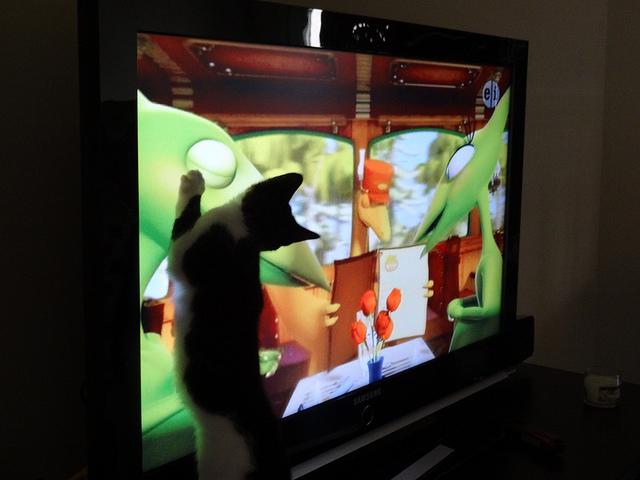What is on TV?
Quick response, please. Cartoons. Is this a 3D TV?
Quick response, please. No. What is the cat doing?
Quick response, please. Watching tv. What sport is the cat watching?
Quick response, please. Cartoon. Which pterodactyl is female?
Short answer required. One on right. Is this cat trying to catch the fish?
Keep it brief. No. What is seen behind the television?
Answer briefly. Wall. 